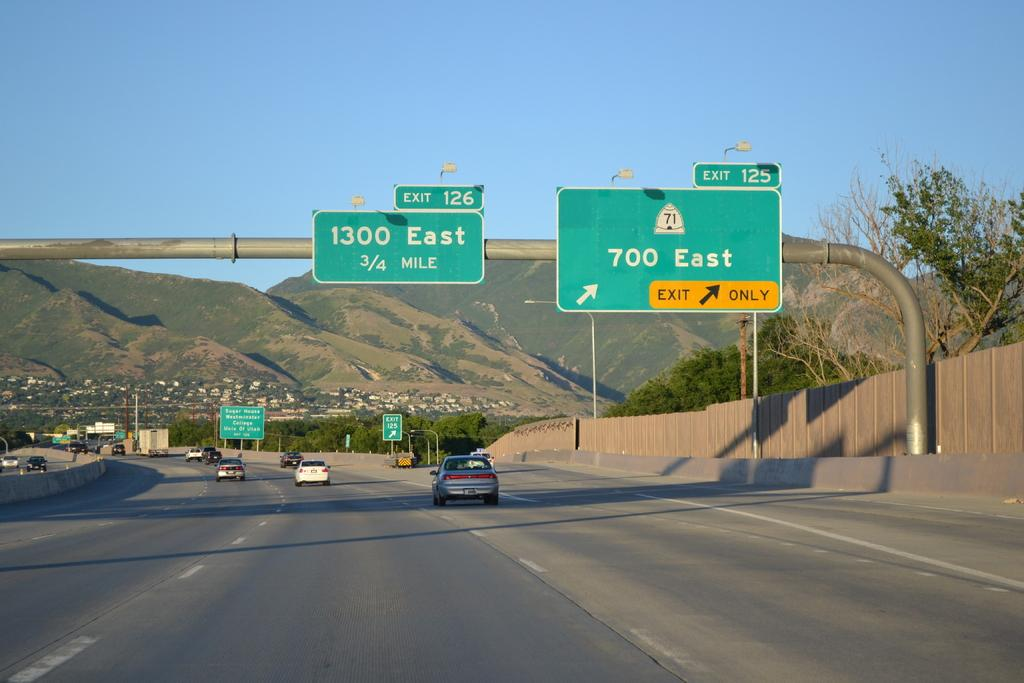<image>
Create a compact narrative representing the image presented. A sign for exit 126 hangs above the highway. 